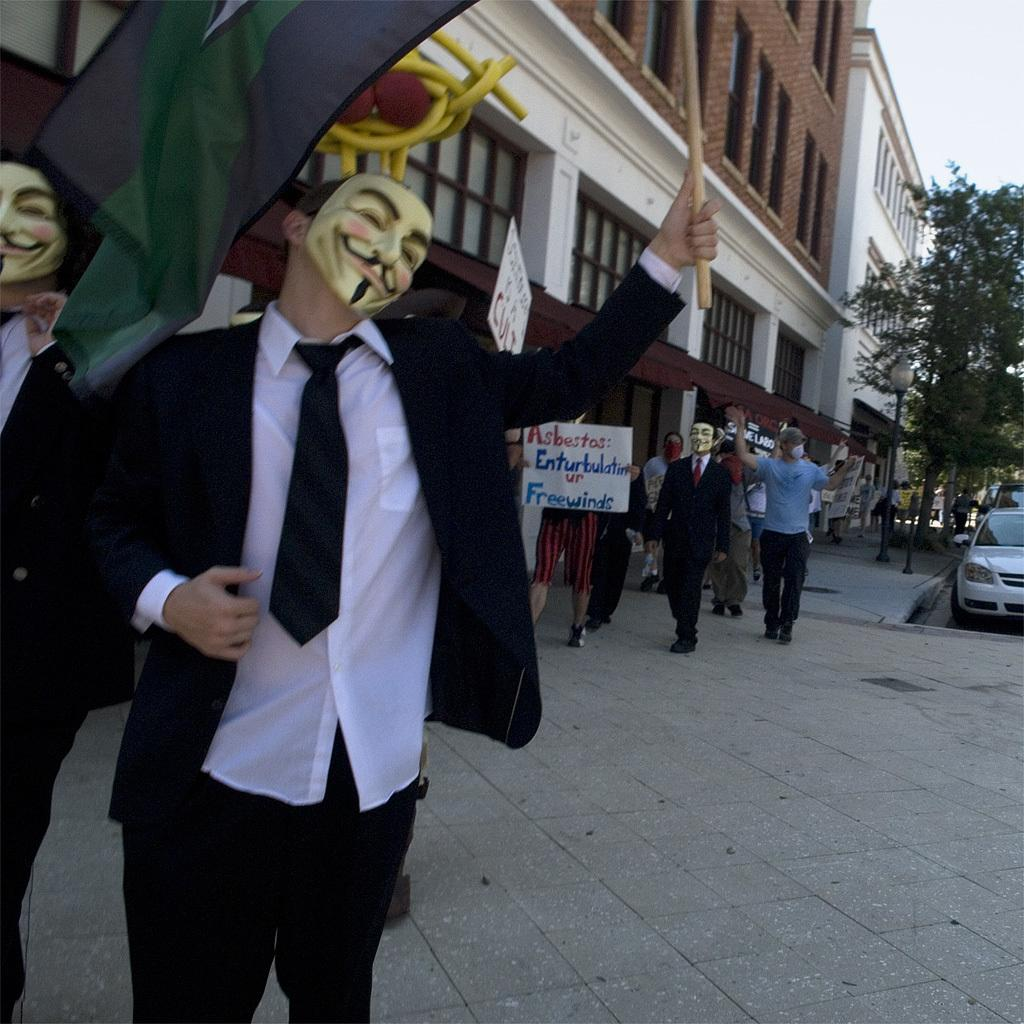What are the people in the image wearing on their faces? The people in the image are wearing masks. What are the people holding in their hands? The people are holding objects in the image. What type of structures can be seen in the background? There are buildings in the image. What mode of transportation is visible in the image? There is a car in the image. What type of vegetation is present in the image? There are trees in the image. What type of signage is present in the image? There are boards with text in the image. What type of jam is being used to paint the car in the image? There is no jam present in the image, and the car is not being painted. 